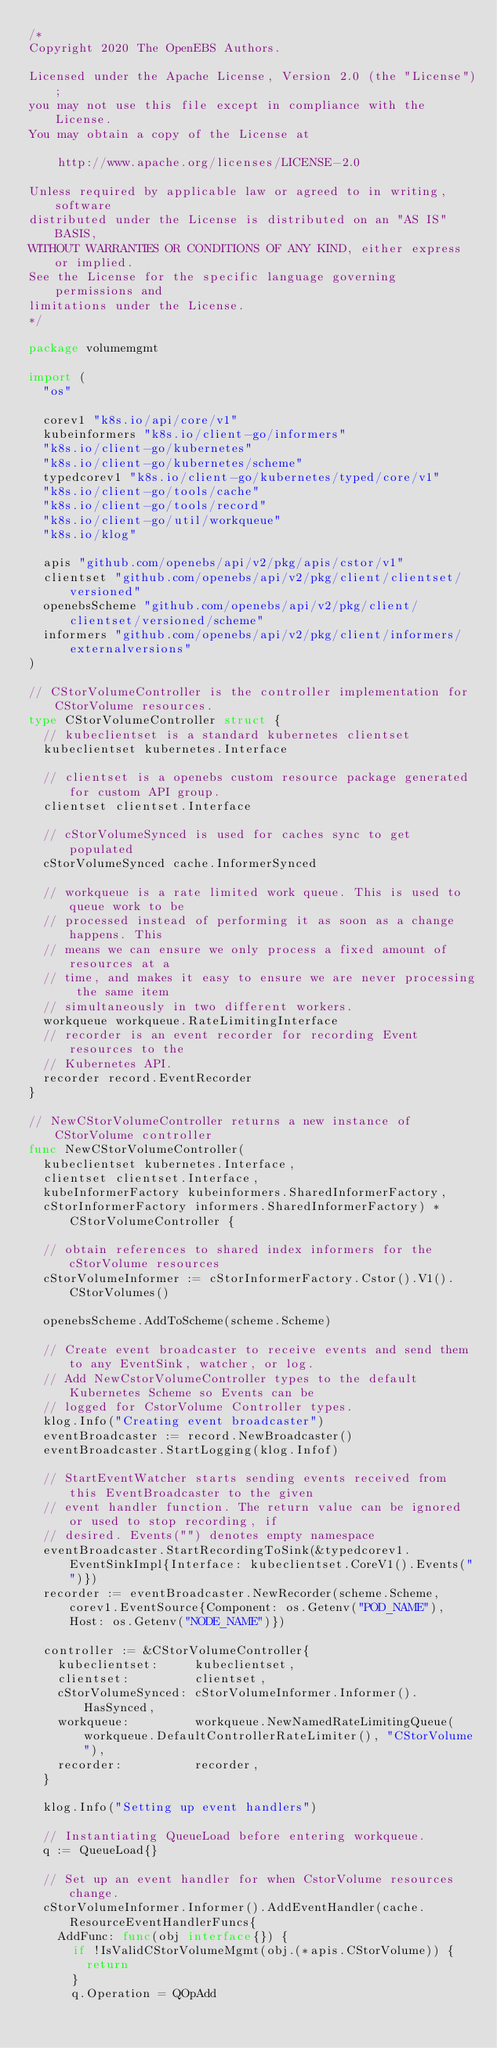<code> <loc_0><loc_0><loc_500><loc_500><_Go_>/*
Copyright 2020 The OpenEBS Authors.

Licensed under the Apache License, Version 2.0 (the "License");
you may not use this file except in compliance with the License.
You may obtain a copy of the License at

    http://www.apache.org/licenses/LICENSE-2.0

Unless required by applicable law or agreed to in writing, software
distributed under the License is distributed on an "AS IS" BASIS,
WITHOUT WARRANTIES OR CONDITIONS OF ANY KIND, either express or implied.
See the License for the specific language governing permissions and
limitations under the License.
*/

package volumemgmt

import (
	"os"

	corev1 "k8s.io/api/core/v1"
	kubeinformers "k8s.io/client-go/informers"
	"k8s.io/client-go/kubernetes"
	"k8s.io/client-go/kubernetes/scheme"
	typedcorev1 "k8s.io/client-go/kubernetes/typed/core/v1"
	"k8s.io/client-go/tools/cache"
	"k8s.io/client-go/tools/record"
	"k8s.io/client-go/util/workqueue"
	"k8s.io/klog"

	apis "github.com/openebs/api/v2/pkg/apis/cstor/v1"
	clientset "github.com/openebs/api/v2/pkg/client/clientset/versioned"
	openebsScheme "github.com/openebs/api/v2/pkg/client/clientset/versioned/scheme"
	informers "github.com/openebs/api/v2/pkg/client/informers/externalversions"
)

// CStorVolumeController is the controller implementation for CStorVolume resources.
type CStorVolumeController struct {
	// kubeclientset is a standard kubernetes clientset
	kubeclientset kubernetes.Interface

	// clientset is a openebs custom resource package generated for custom API group.
	clientset clientset.Interface

	// cStorVolumeSynced is used for caches sync to get populated
	cStorVolumeSynced cache.InformerSynced

	// workqueue is a rate limited work queue. This is used to queue work to be
	// processed instead of performing it as soon as a change happens. This
	// means we can ensure we only process a fixed amount of resources at a
	// time, and makes it easy to ensure we are never processing the same item
	// simultaneously in two different workers.
	workqueue workqueue.RateLimitingInterface
	// recorder is an event recorder for recording Event resources to the
	// Kubernetes API.
	recorder record.EventRecorder
}

// NewCStorVolumeController returns a new instance of CStorVolume controller
func NewCStorVolumeController(
	kubeclientset kubernetes.Interface,
	clientset clientset.Interface,
	kubeInformerFactory kubeinformers.SharedInformerFactory,
	cStorInformerFactory informers.SharedInformerFactory) *CStorVolumeController {

	// obtain references to shared index informers for the cStorVolume resources
	cStorVolumeInformer := cStorInformerFactory.Cstor().V1().CStorVolumes()

	openebsScheme.AddToScheme(scheme.Scheme)

	// Create event broadcaster to receive events and send them to any EventSink, watcher, or log.
	// Add NewCstorVolumeController types to the default Kubernetes Scheme so Events can be
	// logged for CstorVolume Controller types.
	klog.Info("Creating event broadcaster")
	eventBroadcaster := record.NewBroadcaster()
	eventBroadcaster.StartLogging(klog.Infof)

	// StartEventWatcher starts sending events received from this EventBroadcaster to the given
	// event handler function. The return value can be ignored or used to stop recording, if
	// desired. Events("") denotes empty namespace
	eventBroadcaster.StartRecordingToSink(&typedcorev1.EventSinkImpl{Interface: kubeclientset.CoreV1().Events("")})
	recorder := eventBroadcaster.NewRecorder(scheme.Scheme, corev1.EventSource{Component: os.Getenv("POD_NAME"), Host: os.Getenv("NODE_NAME")})

	controller := &CStorVolumeController{
		kubeclientset:     kubeclientset,
		clientset:         clientset,
		cStorVolumeSynced: cStorVolumeInformer.Informer().HasSynced,
		workqueue:         workqueue.NewNamedRateLimitingQueue(workqueue.DefaultControllerRateLimiter(), "CStorVolume"),
		recorder:          recorder,
	}

	klog.Info("Setting up event handlers")

	// Instantiating QueueLoad before entering workqueue.
	q := QueueLoad{}

	// Set up an event handler for when CstorVolume resources change.
	cStorVolumeInformer.Informer().AddEventHandler(cache.ResourceEventHandlerFuncs{
		AddFunc: func(obj interface{}) {
			if !IsValidCStorVolumeMgmt(obj.(*apis.CStorVolume)) {
				return
			}
			q.Operation = QOpAdd</code> 